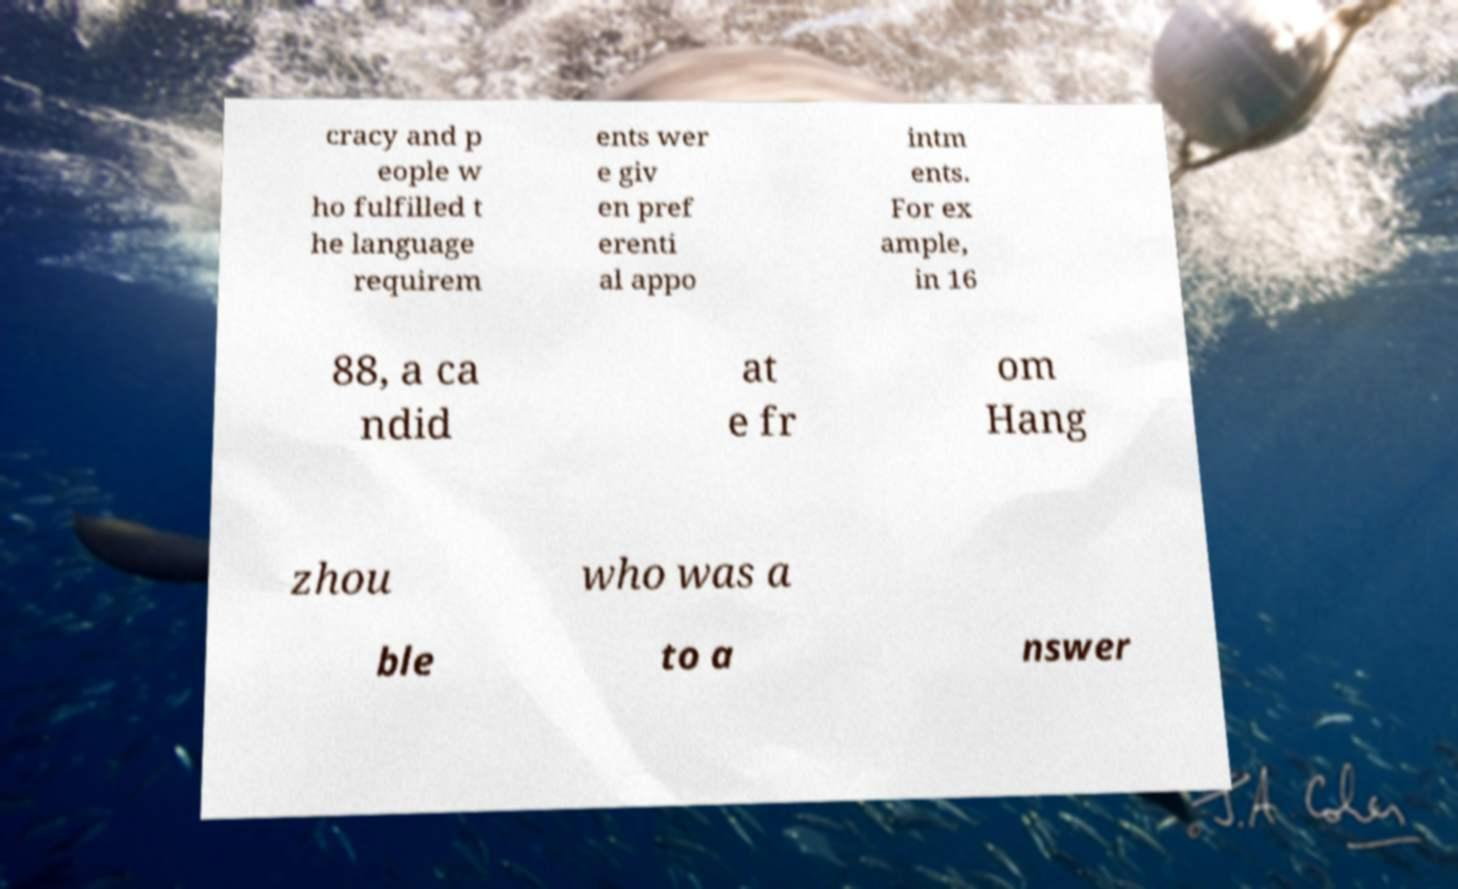For documentation purposes, I need the text within this image transcribed. Could you provide that? cracy and p eople w ho fulfilled t he language requirem ents wer e giv en pref erenti al appo intm ents. For ex ample, in 16 88, a ca ndid at e fr om Hang zhou who was a ble to a nswer 